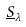<formula> <loc_0><loc_0><loc_500><loc_500>\underline { S } _ { \lambda }</formula> 